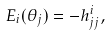Convert formula to latex. <formula><loc_0><loc_0><loc_500><loc_500>E _ { i } ( \theta _ { j } ) = - h _ { j j } ^ { i } ,</formula> 